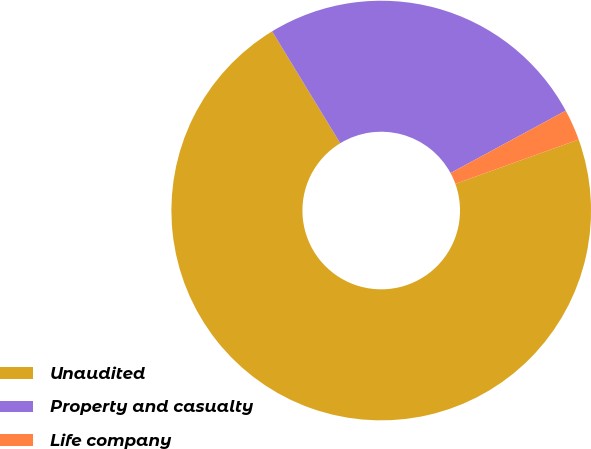<chart> <loc_0><loc_0><loc_500><loc_500><pie_chart><fcel>Unaudited<fcel>Property and casualty<fcel>Life company<nl><fcel>71.8%<fcel>25.81%<fcel>2.4%<nl></chart> 